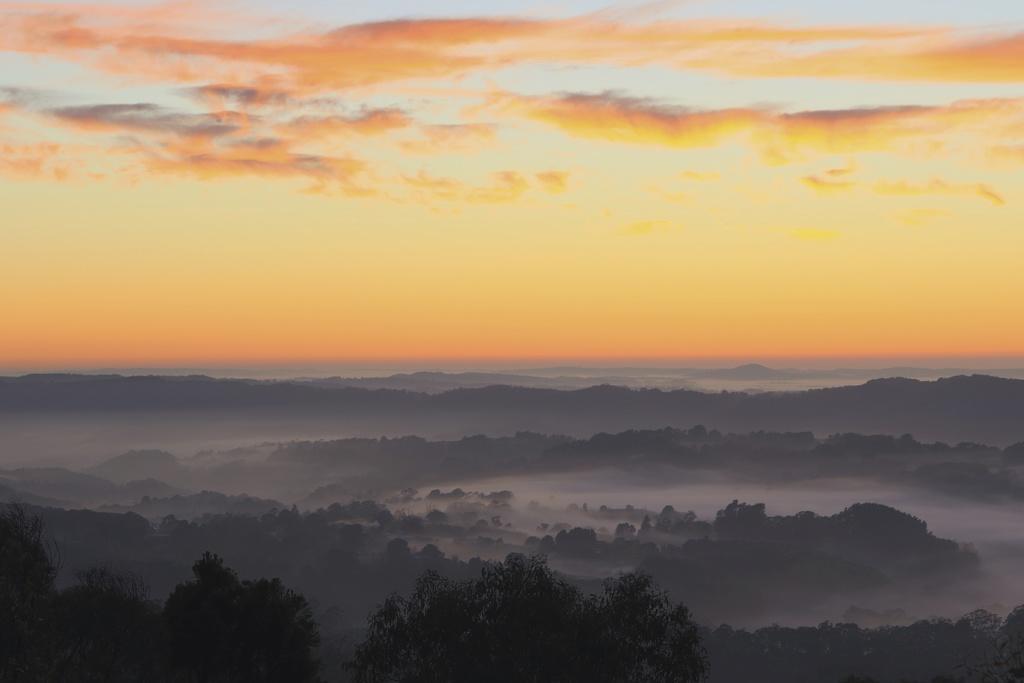Could you give a brief overview of what you see in this image? In this picture we can see there are hills. At the bottom of the image, there are trees. At the top of the image, there is the sky. 